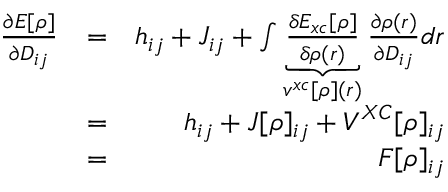<formula> <loc_0><loc_0><loc_500><loc_500>\begin{array} { r l r } { \frac { \partial E [ \rho ] } { \partial D _ { i j } } } & { = } & { h _ { i j } + J _ { i j } + \int \underbrace { \frac { \delta E _ { x c } [ \rho ] } { \delta \rho ( r ) } } _ { v ^ { x c } [ \rho ] ( r ) } \frac { \partial \rho ( r ) } { \partial D _ { i j } } d r } \\ & { = } & { h _ { i j } + J [ \rho ] _ { i j } + V ^ { X C } [ \rho ] _ { i j } } \\ & { = } & { F [ \rho ] _ { i j } } \end{array}</formula> 